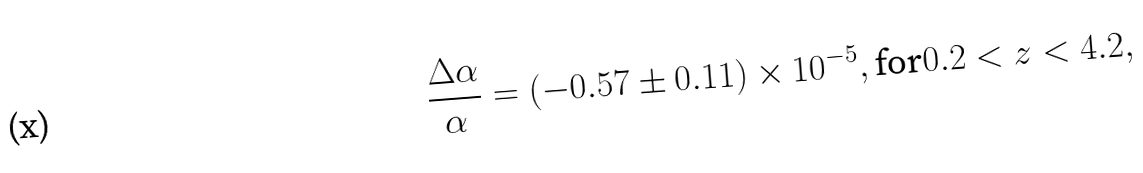Convert formula to latex. <formula><loc_0><loc_0><loc_500><loc_500>\frac { \Delta \alpha } { \alpha } = ( - 0 . 5 7 \pm 0 . 1 1 ) \times 1 0 ^ { - 5 } , \text {for} 0 . 2 < z < 4 . 2 ,</formula> 